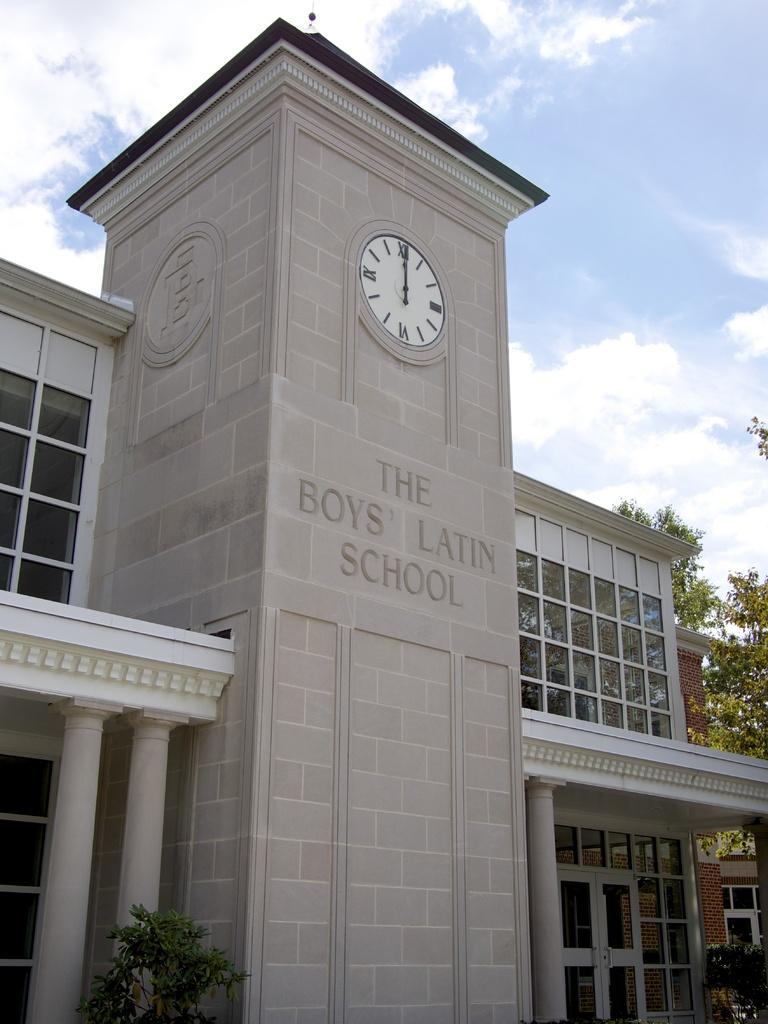<image>
Give a short and clear explanation of the subsequent image. A clock above the sign "The Boys' Latin School" shows 12. 